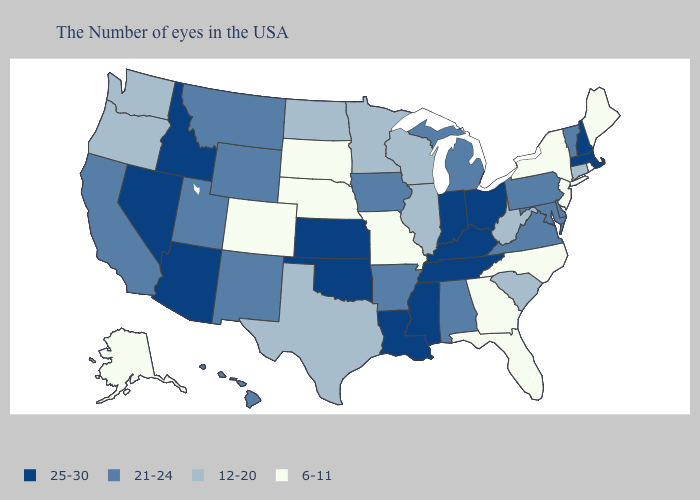Does Pennsylvania have the lowest value in the Northeast?
Quick response, please. No. Does Oklahoma have a higher value than New Mexico?
Concise answer only. Yes. Does Hawaii have the same value as Delaware?
Concise answer only. Yes. What is the value of Florida?
Answer briefly. 6-11. Among the states that border New Jersey , does Delaware have the lowest value?
Keep it brief. No. Does West Virginia have the lowest value in the USA?
Answer briefly. No. Which states have the lowest value in the Northeast?
Answer briefly. Maine, Rhode Island, New York, New Jersey. Name the states that have a value in the range 6-11?
Short answer required. Maine, Rhode Island, New York, New Jersey, North Carolina, Florida, Georgia, Missouri, Nebraska, South Dakota, Colorado, Alaska. Does Nebraska have the same value as Alaska?
Answer briefly. Yes. Which states have the lowest value in the USA?
Give a very brief answer. Maine, Rhode Island, New York, New Jersey, North Carolina, Florida, Georgia, Missouri, Nebraska, South Dakota, Colorado, Alaska. What is the value of Maryland?
Keep it brief. 21-24. Does Pennsylvania have the highest value in the Northeast?
Write a very short answer. No. What is the value of Pennsylvania?
Be succinct. 21-24. Does Georgia have a higher value than New Jersey?
Short answer required. No. Does Illinois have the same value as Vermont?
Short answer required. No. 